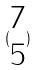<formula> <loc_0><loc_0><loc_500><loc_500>( \begin{matrix} 7 \\ 5 \end{matrix} )</formula> 